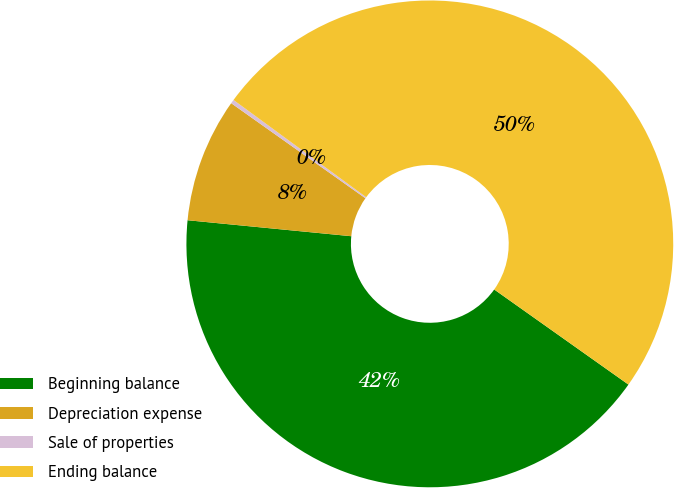Convert chart to OTSL. <chart><loc_0><loc_0><loc_500><loc_500><pie_chart><fcel>Beginning balance<fcel>Depreciation expense<fcel>Sale of properties<fcel>Ending balance<nl><fcel>41.74%<fcel>8.26%<fcel>0.26%<fcel>49.74%<nl></chart> 